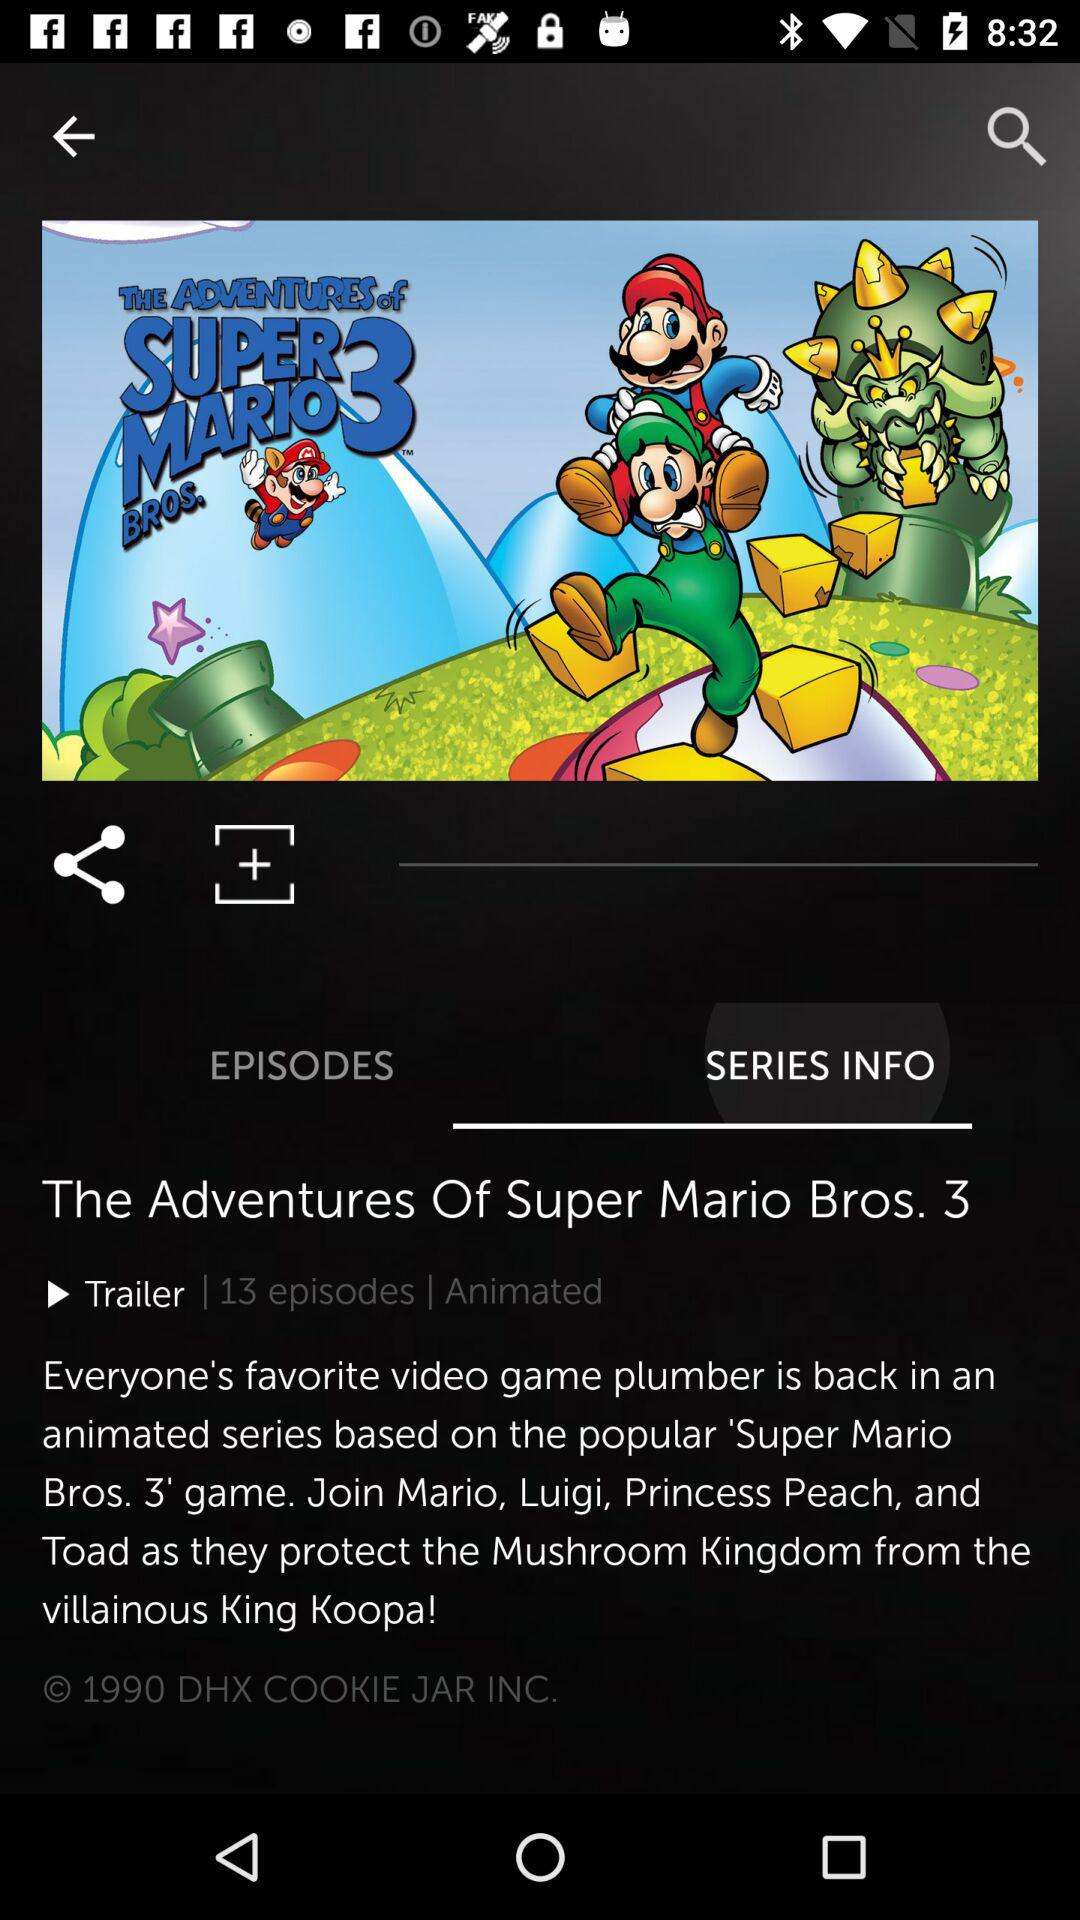How many episodes are there? There are 13 episodes. 